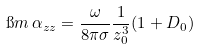Convert formula to latex. <formula><loc_0><loc_0><loc_500><loc_500>\i m \, \alpha _ { z z } = \frac { \omega } { 8 \pi \sigma } \frac { 1 } { z _ { 0 } ^ { 3 } } ( 1 + D _ { 0 } )</formula> 